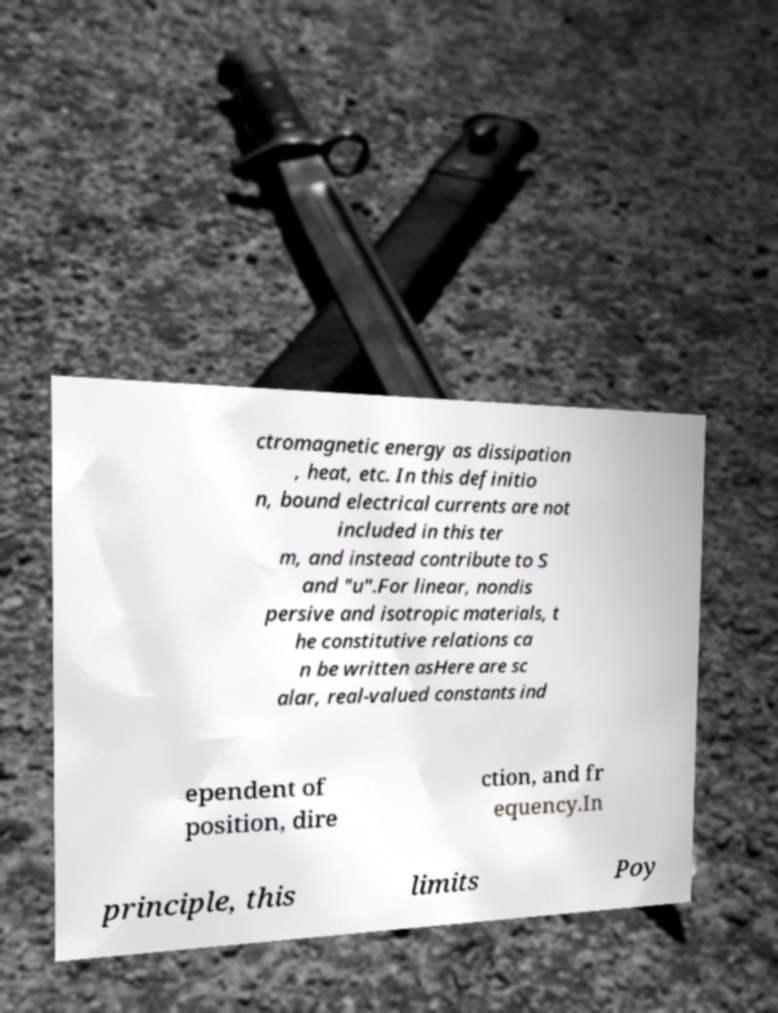Can you accurately transcribe the text from the provided image for me? ctromagnetic energy as dissipation , heat, etc. In this definitio n, bound electrical currents are not included in this ter m, and instead contribute to S and "u".For linear, nondis persive and isotropic materials, t he constitutive relations ca n be written asHere are sc alar, real-valued constants ind ependent of position, dire ction, and fr equency.In principle, this limits Poy 